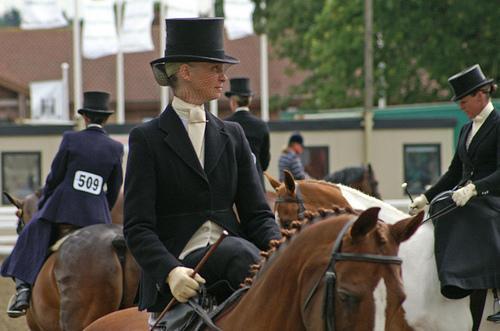How many riders are there?
Give a very brief answer. 5. 